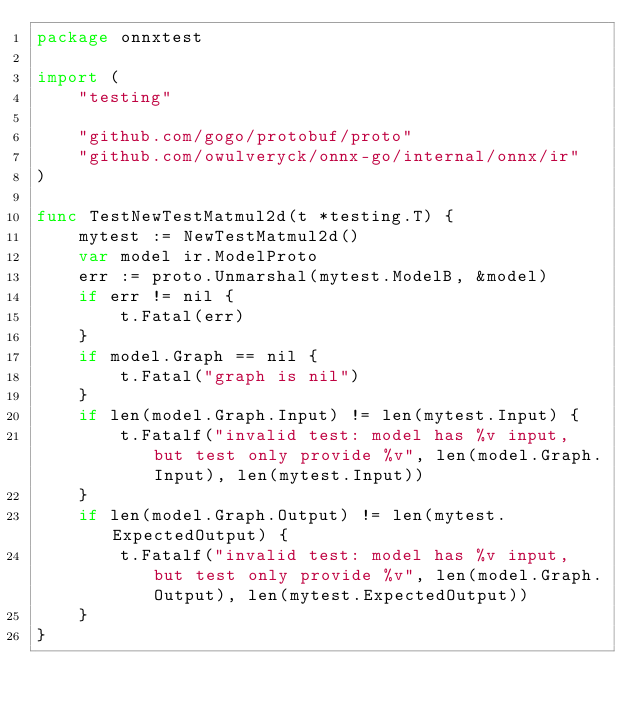Convert code to text. <code><loc_0><loc_0><loc_500><loc_500><_Go_>package onnxtest

import (
	"testing"

	"github.com/gogo/protobuf/proto"
	"github.com/owulveryck/onnx-go/internal/onnx/ir"
)

func TestNewTestMatmul2d(t *testing.T) {
	mytest := NewTestMatmul2d()
	var model ir.ModelProto
	err := proto.Unmarshal(mytest.ModelB, &model)
	if err != nil {
		t.Fatal(err)
	}
	if model.Graph == nil {
		t.Fatal("graph is nil")
	}
	if len(model.Graph.Input) != len(mytest.Input) {
		t.Fatalf("invalid test: model has %v input, but test only provide %v", len(model.Graph.Input), len(mytest.Input))
	}
	if len(model.Graph.Output) != len(mytest.ExpectedOutput) {
		t.Fatalf("invalid test: model has %v input, but test only provide %v", len(model.Graph.Output), len(mytest.ExpectedOutput))
	}
}
</code> 